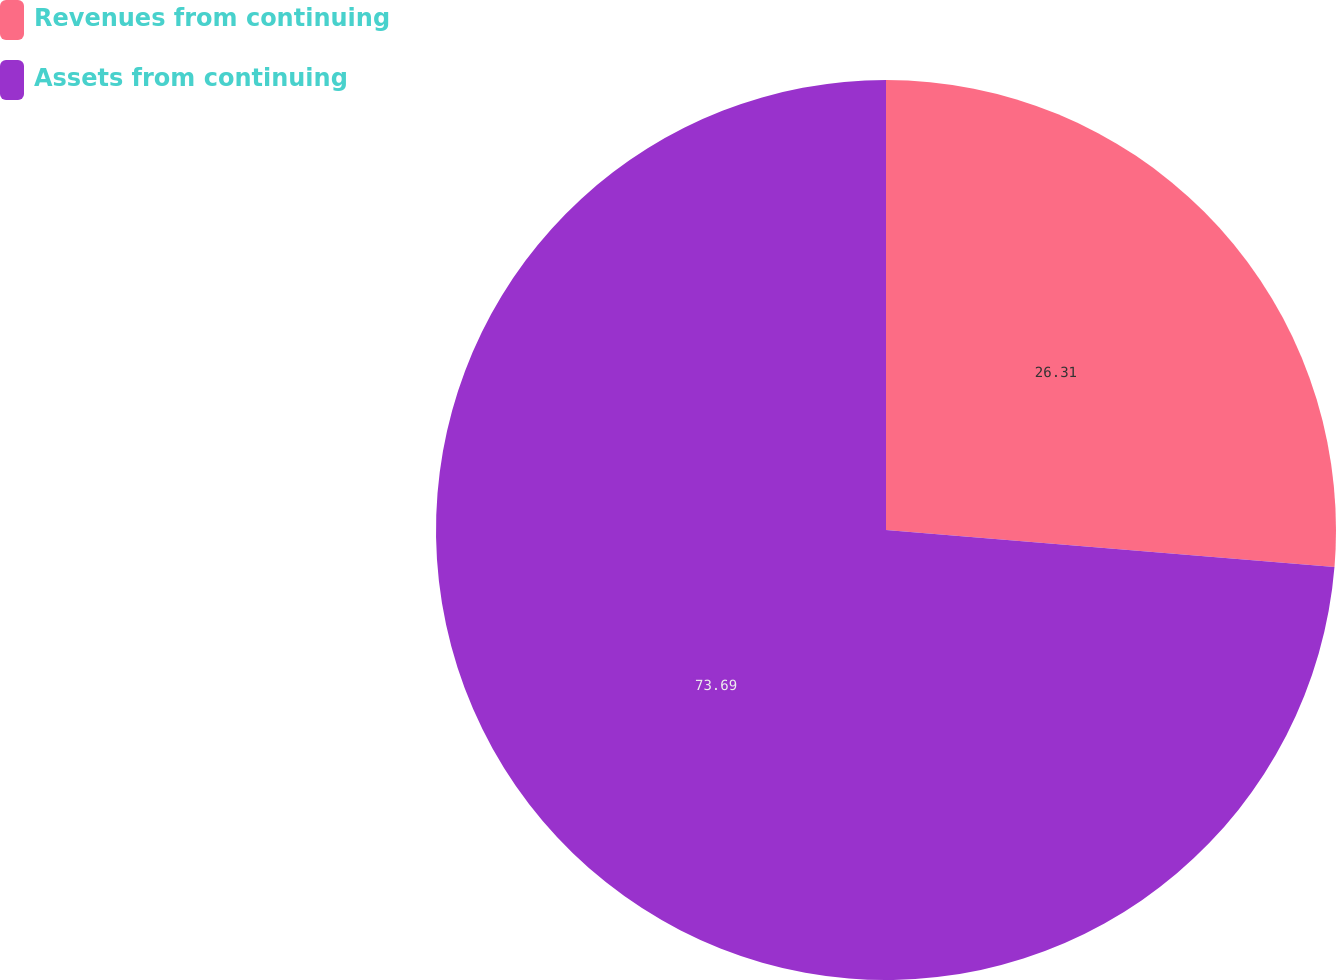Convert chart to OTSL. <chart><loc_0><loc_0><loc_500><loc_500><pie_chart><fcel>Revenues from continuing<fcel>Assets from continuing<nl><fcel>26.31%<fcel>73.69%<nl></chart> 